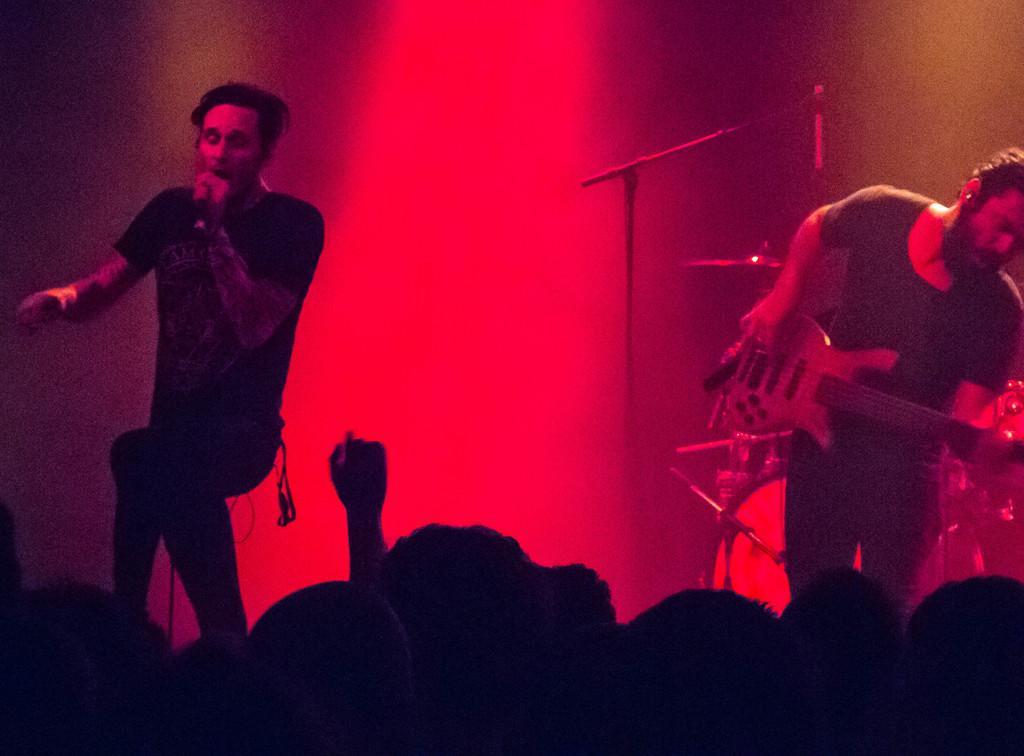Describe this image in one or two sentences. 2 people are performing on the stage. the person at the right is playing guitar. the person at the right is singing. people are watching them. 